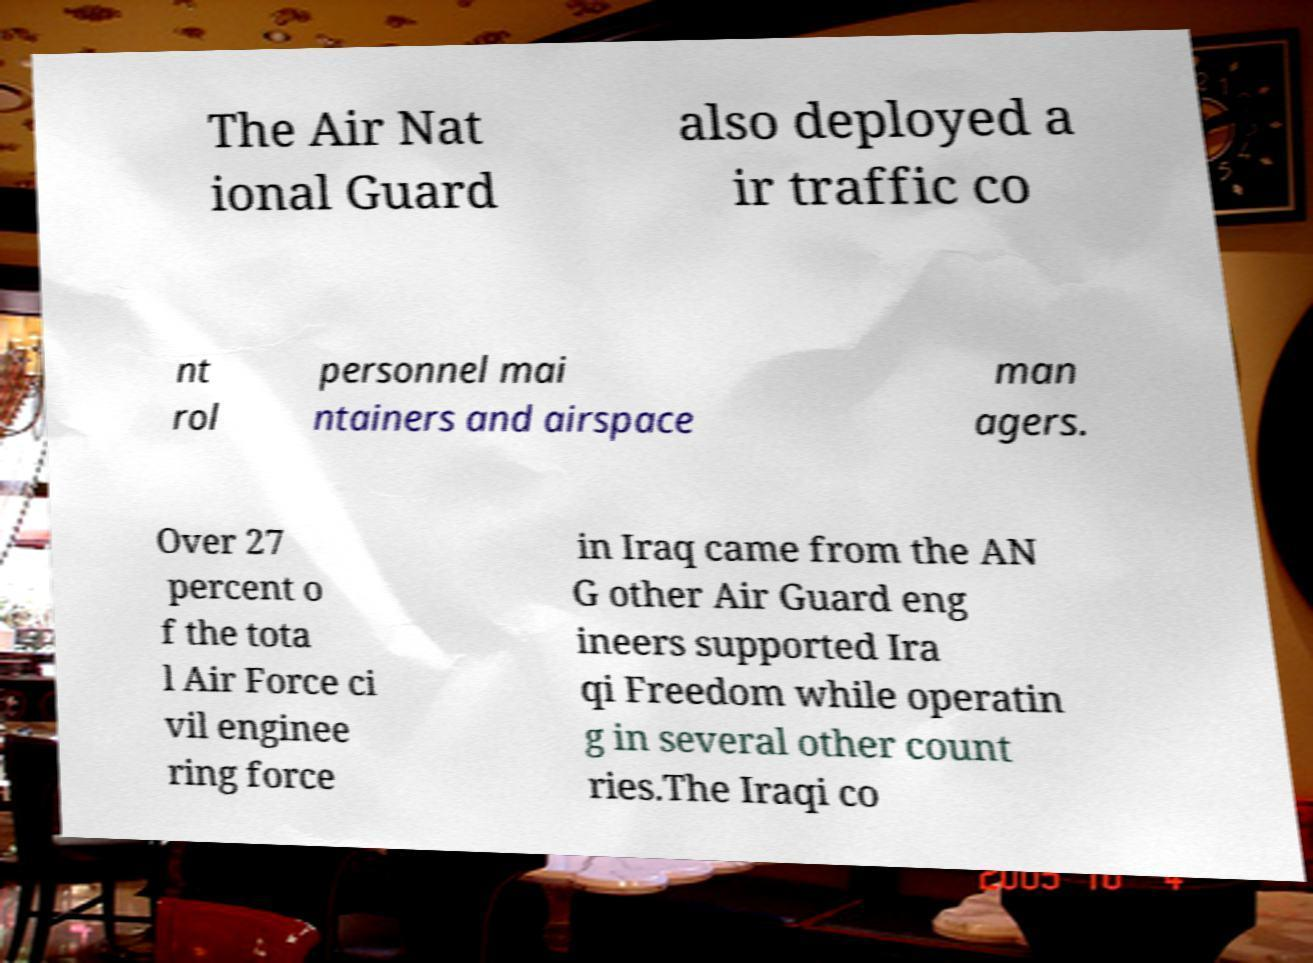What messages or text are displayed in this image? I need them in a readable, typed format. The Air Nat ional Guard also deployed a ir traffic co nt rol personnel mai ntainers and airspace man agers. Over 27 percent o f the tota l Air Force ci vil enginee ring force in Iraq came from the AN G other Air Guard eng ineers supported Ira qi Freedom while operatin g in several other count ries.The Iraqi co 